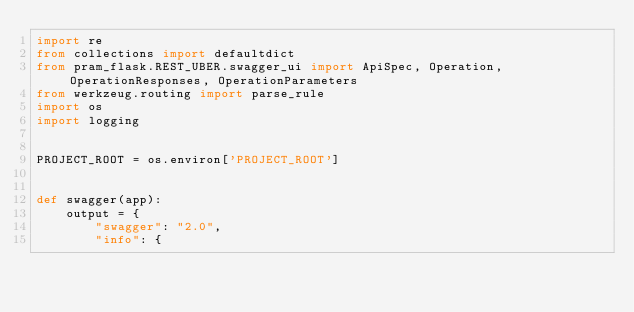Convert code to text. <code><loc_0><loc_0><loc_500><loc_500><_Python_>import re
from collections import defaultdict
from pram_flask.REST_UBER.swagger_ui import ApiSpec, Operation, OperationResponses, OperationParameters
from werkzeug.routing import parse_rule
import os
import logging


PROJECT_ROOT = os.environ['PROJECT_ROOT']


def swagger(app):
    output = {
        "swagger": "2.0",
        "info": {</code> 